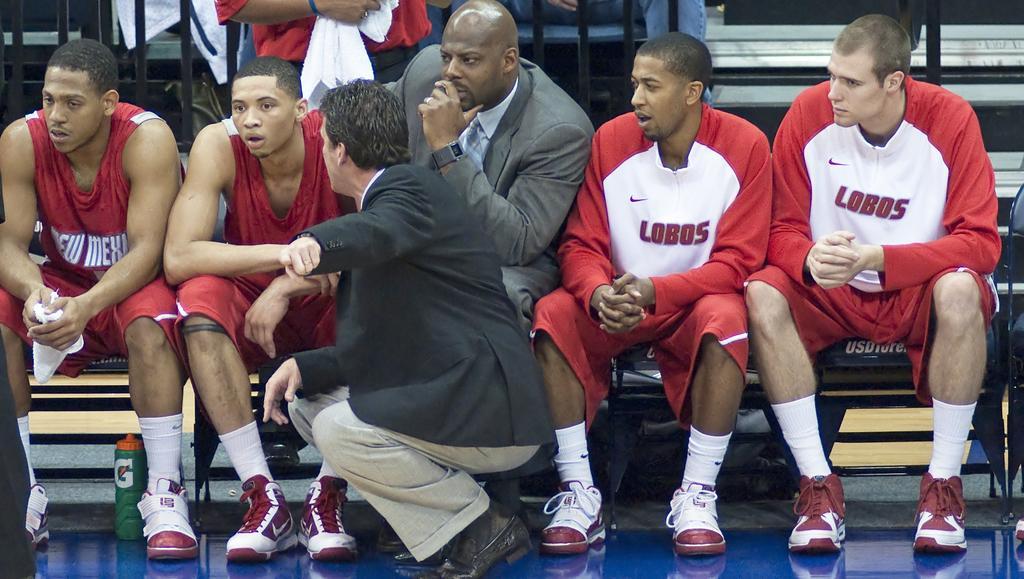Describe this image in one or two sentences. In the image there are few men in red vest sitting in the left side and in the middle there is a man in coat and beside him two other men in red dress, they all seems to be sports person, in the middle there is a man in squat position, behind them there are steps with some people sitting on it. 